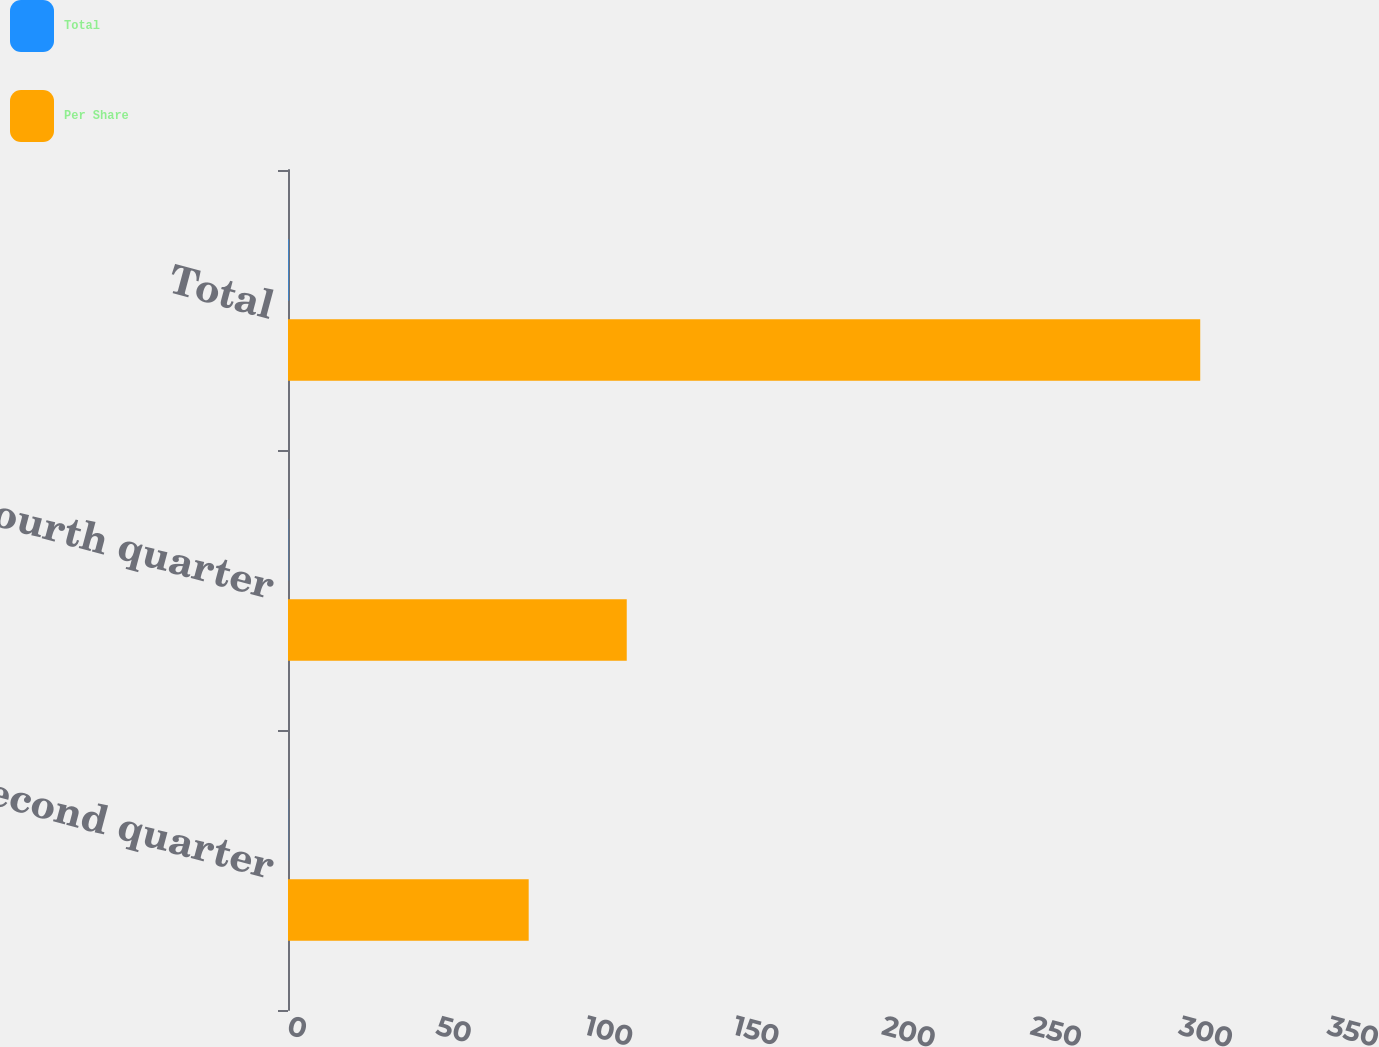<chart> <loc_0><loc_0><loc_500><loc_500><stacked_bar_chart><ecel><fcel>Second quarter<fcel>Fourth quarter<fcel>Total<nl><fcel>Total<fcel>0.05<fcel>0.07<fcel>0.19<nl><fcel>Per Share<fcel>81<fcel>114<fcel>307<nl></chart> 